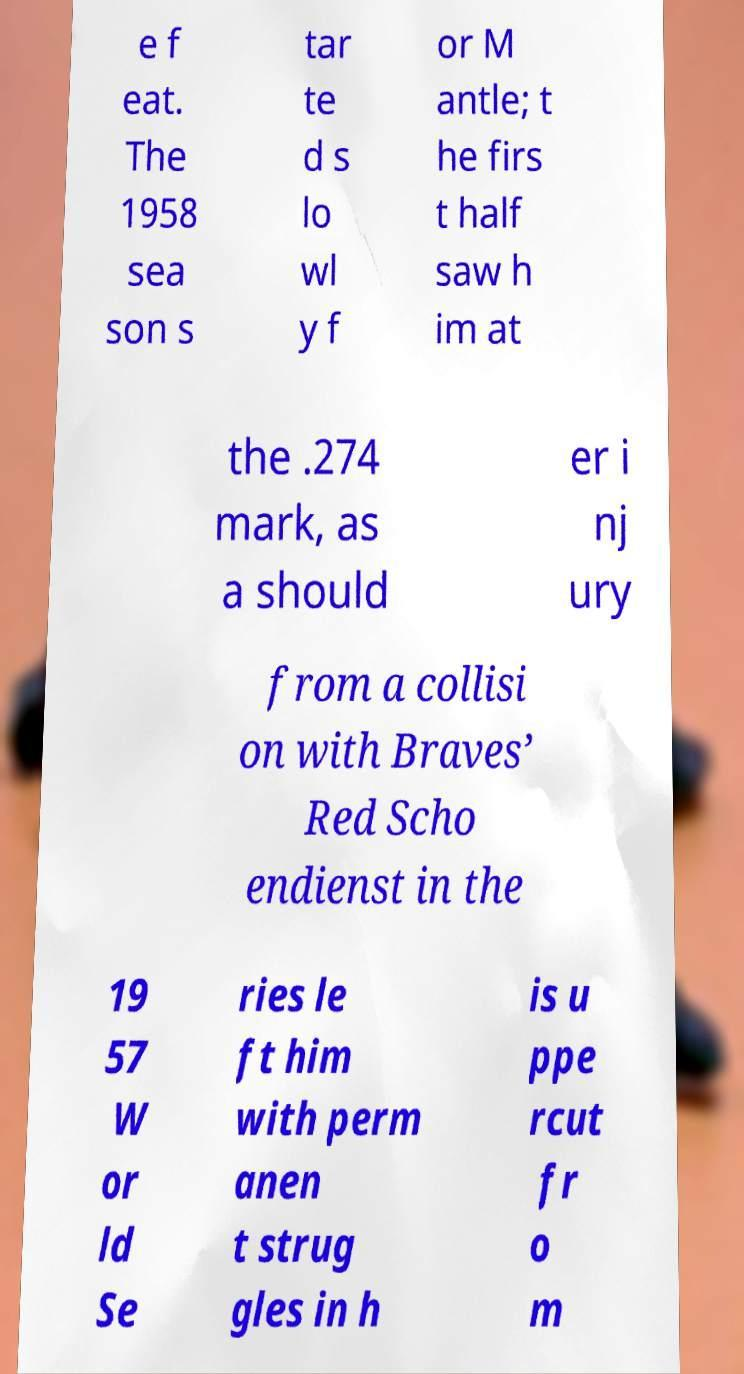Could you assist in decoding the text presented in this image and type it out clearly? e f eat. The 1958 sea son s tar te d s lo wl y f or M antle; t he firs t half saw h im at the .274 mark, as a should er i nj ury from a collisi on with Braves’ Red Scho endienst in the 19 57 W or ld Se ries le ft him with perm anen t strug gles in h is u ppe rcut fr o m 